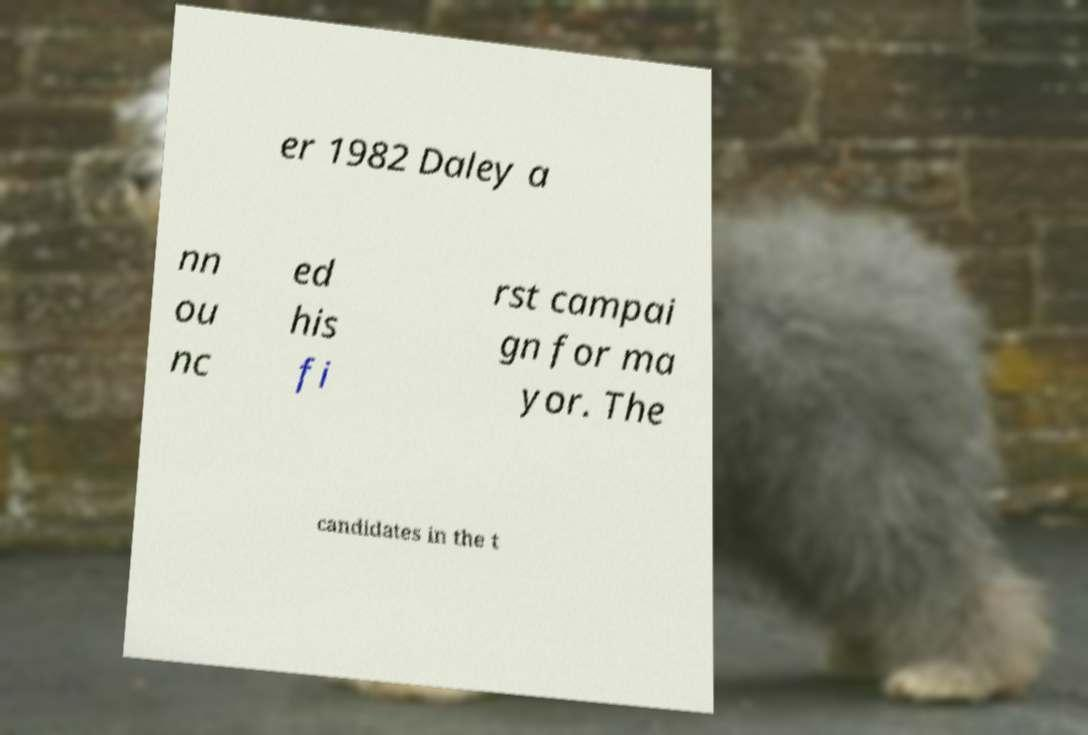Could you extract and type out the text from this image? er 1982 Daley a nn ou nc ed his fi rst campai gn for ma yor. The candidates in the t 